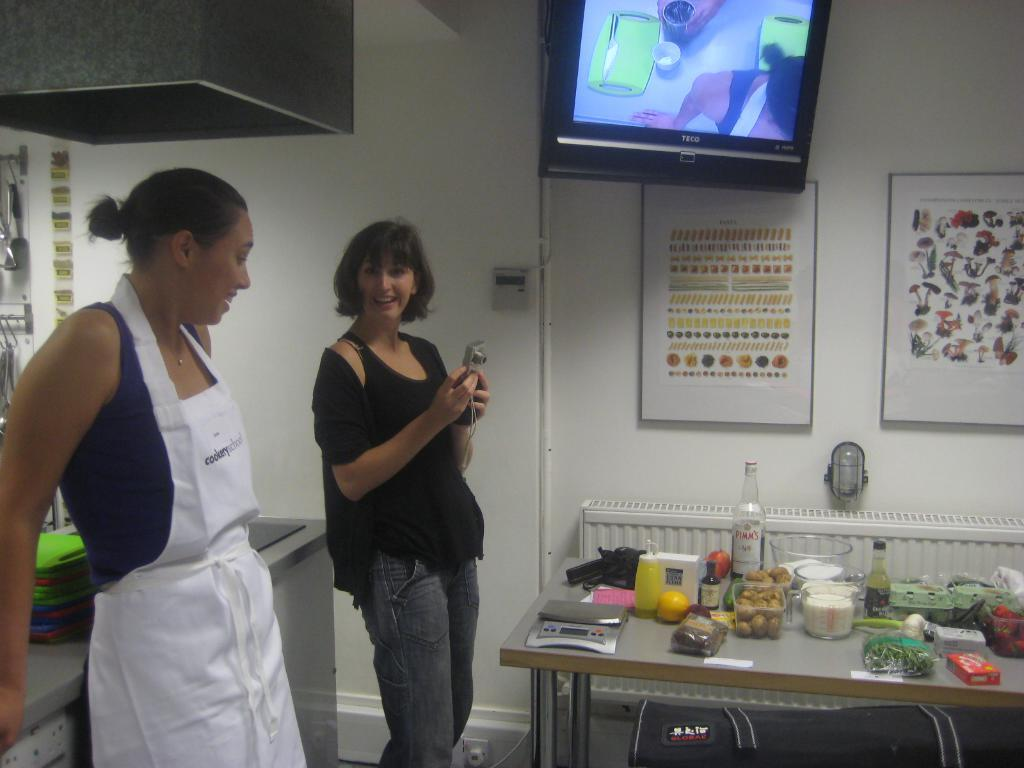<image>
Provide a brief description of the given image. Two women standing in front of a table with a bottle that saysPimm's. 